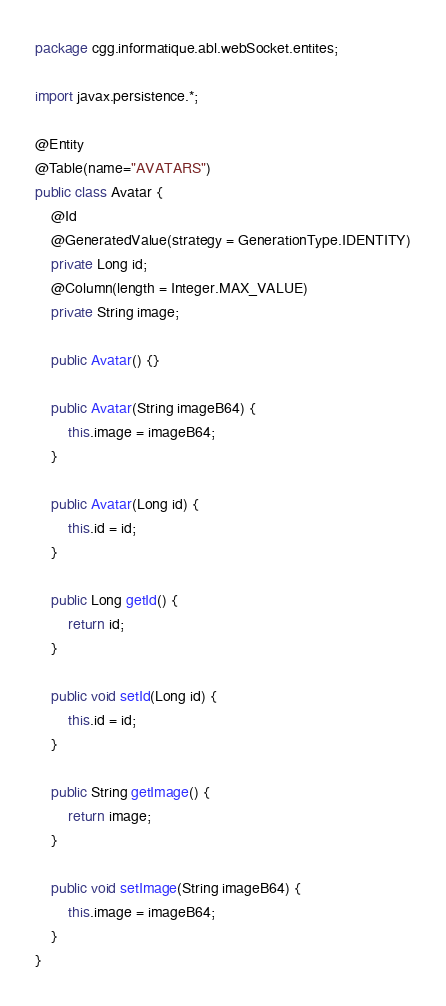Convert code to text. <code><loc_0><loc_0><loc_500><loc_500><_Java_>package cgg.informatique.abl.webSocket.entites;

import javax.persistence.*;

@Entity
@Table(name="AVATARS")
public class Avatar {
    @Id
    @GeneratedValue(strategy = GenerationType.IDENTITY)
    private Long id;
    @Column(length = Integer.MAX_VALUE)
    private String image;

    public Avatar() {}

    public Avatar(String imageB64) {
        this.image = imageB64;
    }

    public Avatar(Long id) {
        this.id = id;
    }

    public Long getId() {
        return id;
    }

    public void setId(Long id) {
        this.id = id;
    }

    public String getImage() {
        return image;
    }

    public void setImage(String imageB64) {
        this.image = imageB64;
    }
}
</code> 